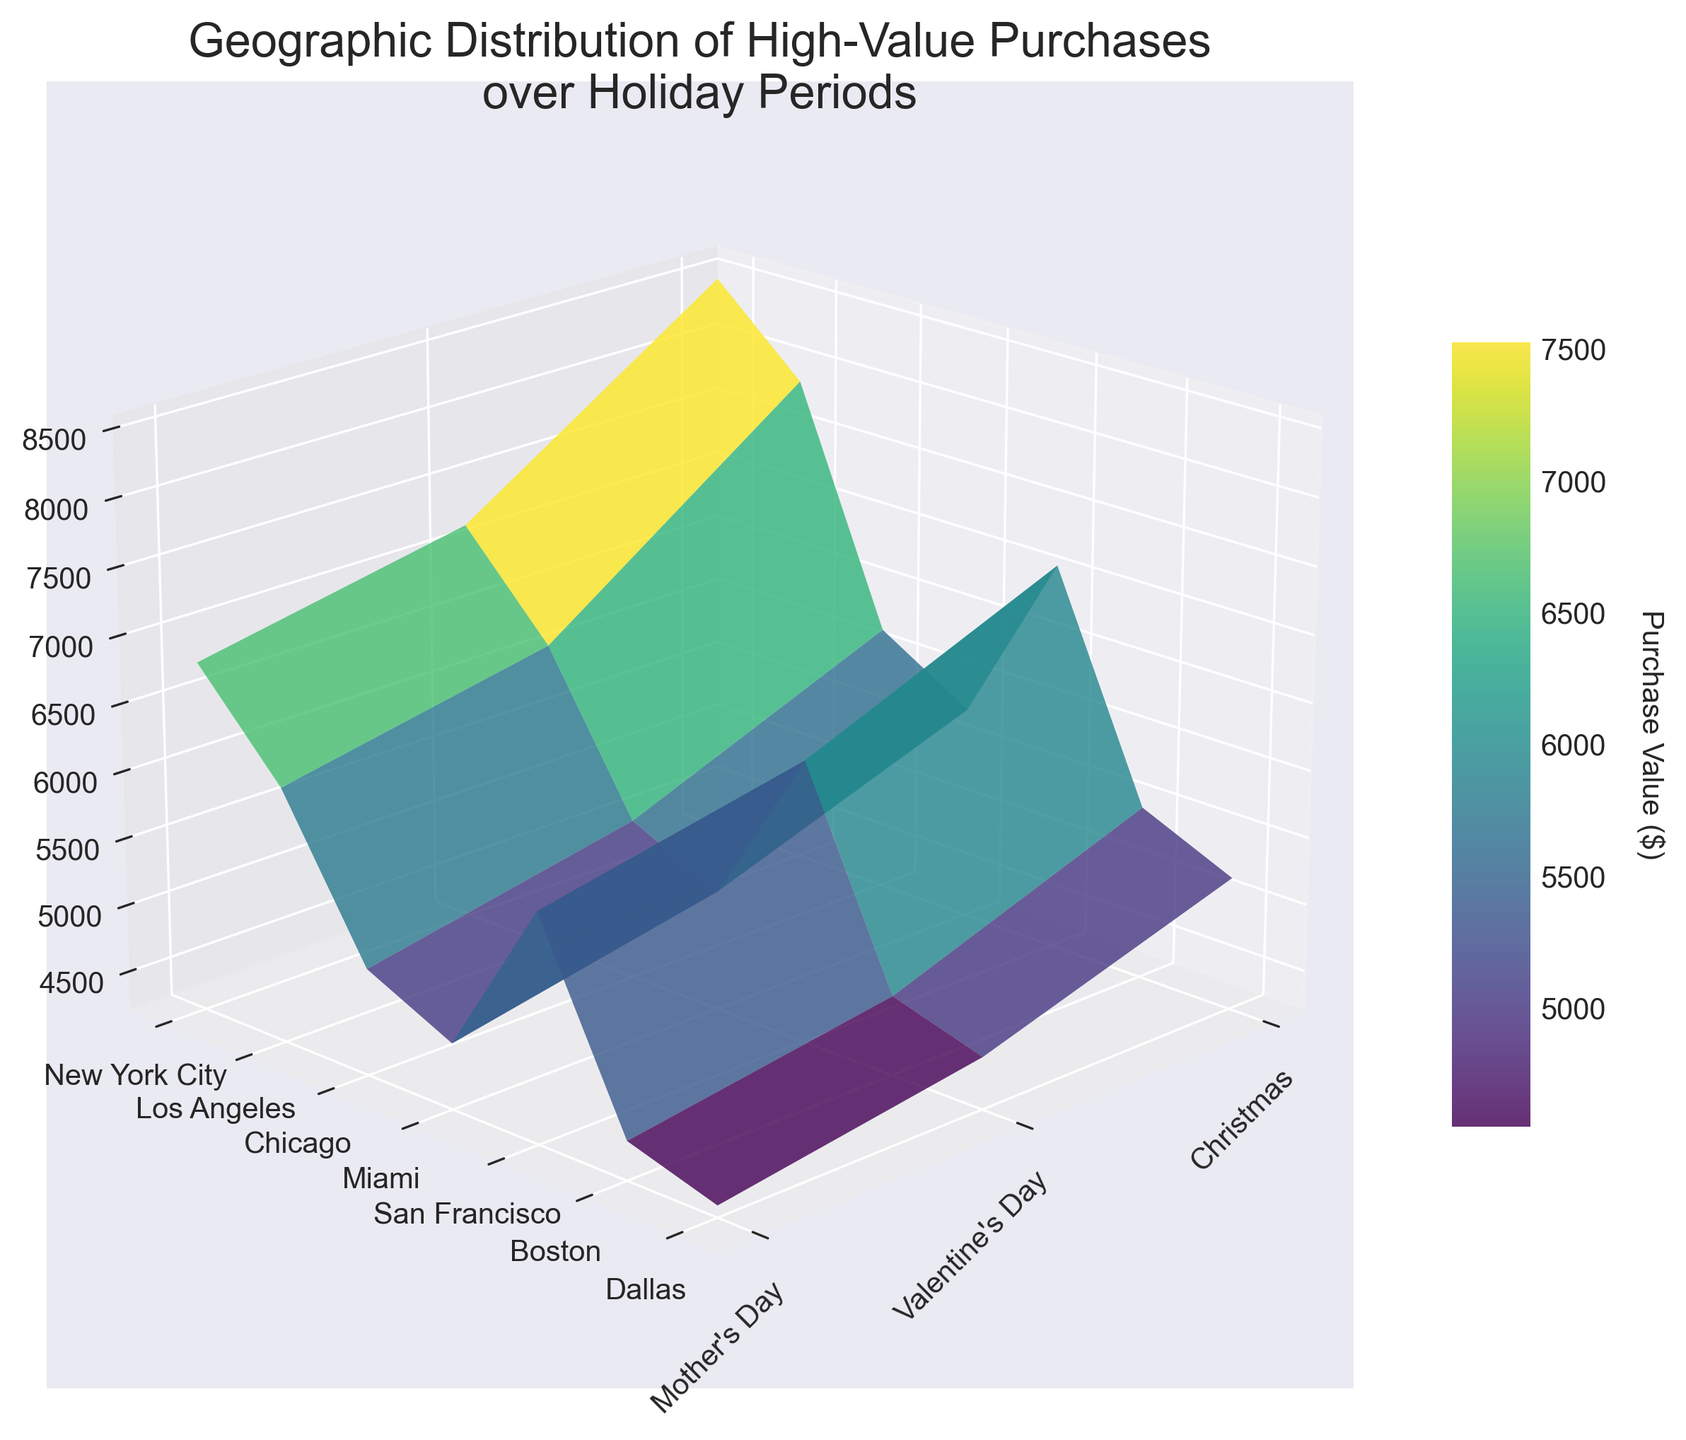What is the title of the plot? The title is located at the top of the plot and provides an overview of the information depicted.
Answer: Geographic Distribution of High-Value Purchases over Holiday Periods Which city has the highest purchase value on Valentine's Day? By observing the surface plot and locating the peaks corresponding to Valentine's Day for each city, you can identify the highest point.
Answer: New York City What is the trend in purchase values for Christmas across all cities? Looking at the plot along the Christmas axis, identify and compare the heights of the bars representing each city.
Answer: Decreasing from New York City to Dallas Which holiday has the lowest overall purchases across all cities? By observing the surface levels corresponding to each holiday, you can determine which holiday has the lowest peaks across all cities.
Answer: Mother’s Day Which city shows the most significant drop in purchase value from Christmas to Mother's Day? Observe the Z values from Christmas to Mother’s Day for each city and find the steepest decline.
Answer: New York City What is the purchase value difference between Los Angeles and San Francisco for Mother's Day? Locate the Z values for Los Angeles and San Francisco on Mother's Day and compute the difference.
Answer: 2100 (6100 - 5900) How do purchase values compare between New York City and Miami for Valentine's Day? Compare the peaks corresponding to Valentine's Day for New York City and Miami by observing their Z values.
Answer: New York City's values are higher Which city has the most consistent purchase values across all holidays? Identify the city with the smallest range of Z values by visually assessing their peaks' relative stability.
Answer: Dallas Based on the colorbar, what color probably represents purchase values around $7000? Refer to the color gradient in the colorbar to find the corresponding hue for values near $7000.
Answer: Green to Yellow What is the average purchase value for San Francisco across all holidays? Identify the Z values for San Francisco for each holiday, add them together and divide by the number of values. (7100 + 6300 + 5900) / 3 = 6433.33
Answer: 6433.33 